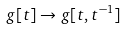Convert formula to latex. <formula><loc_0><loc_0><loc_500><loc_500>g [ t ] \rightarrow g [ t , t ^ { - 1 } ]</formula> 